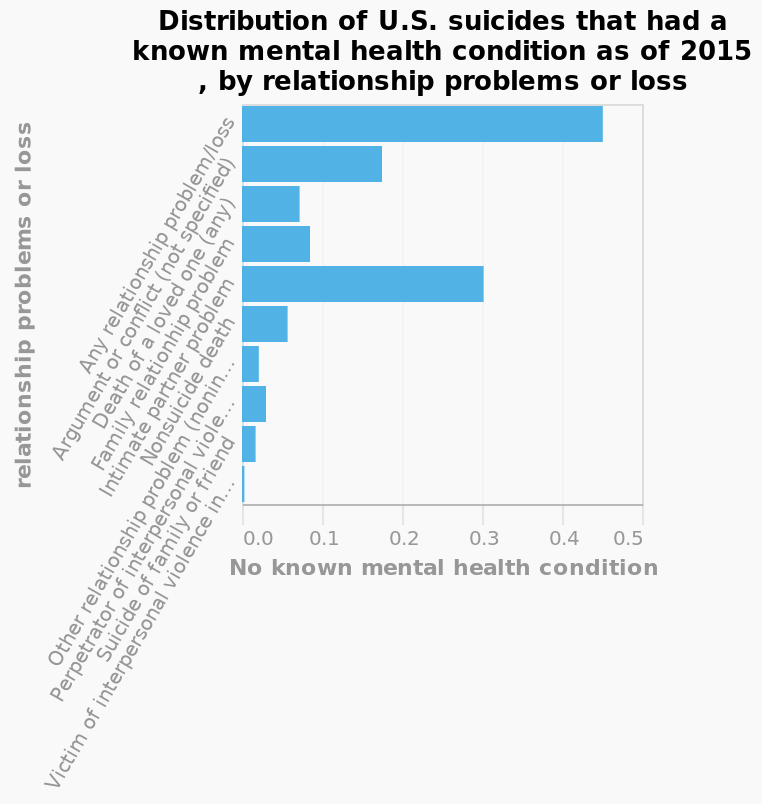<image>
please summary the statistics and relations of the chart I genuinely do not understand what this graph is trying to show. I can't work out whether it means the person had a mental health condition or not. The y-axis is also extremely confusing by how the text is presented. What is measured along the y-axis of the bar plot?  Along the y-axis, the bar plot measures "relationship problems or loss." What is marked on the x-axis? The x-axis is marked with "No known mental health condition." What makes the y-axis extremely confusing based on the text presentation? The way the text is presented on the y-axis is causing extreme confusion for the person. 